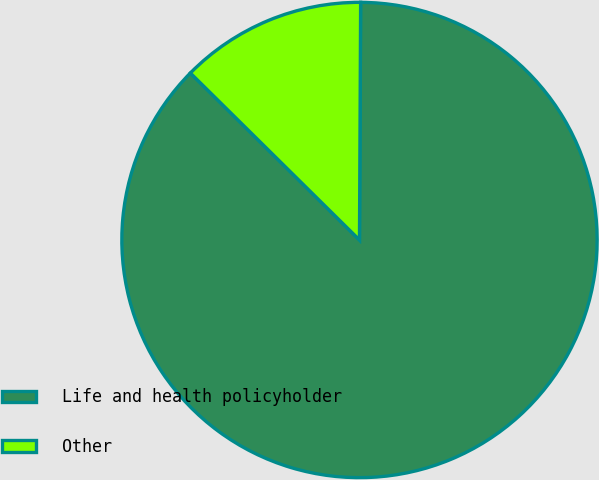Convert chart to OTSL. <chart><loc_0><loc_0><loc_500><loc_500><pie_chart><fcel>Life and health policyholder<fcel>Other<nl><fcel>87.32%<fcel>12.68%<nl></chart> 